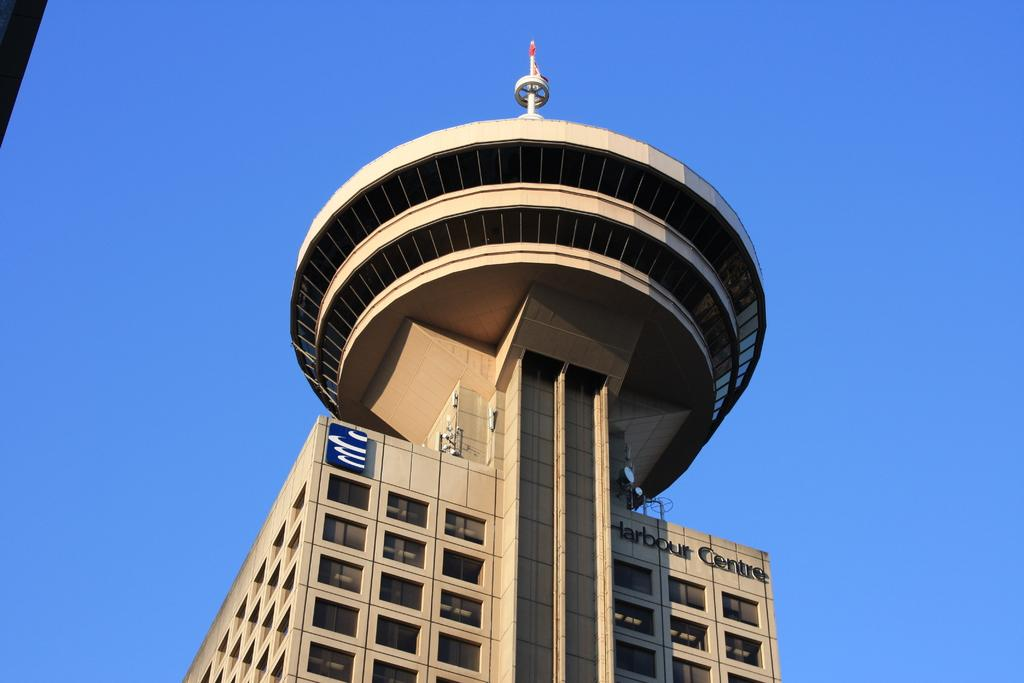What can be seen in the background of the image? There is a sky visible in the image. What type of structure is present in the image? There is a building in the image. What architectural feature can be seen on the building? There are windows in the image. What type of horn is attached to the side of the building in the image? There is no horn attached to the side of the building in the image. What type of canvas is covering the windows in the image? There is no canvas covering the windows in the image. 